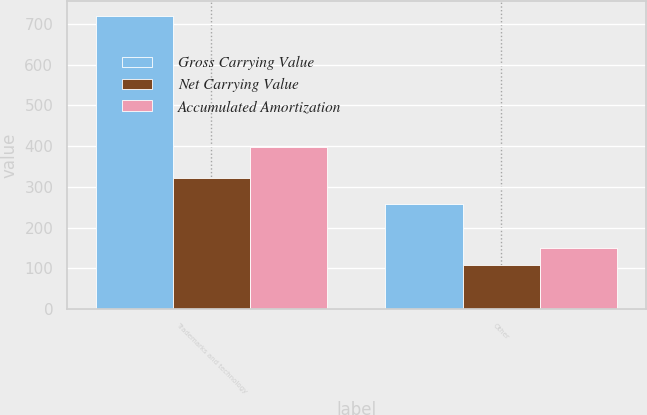Convert chart to OTSL. <chart><loc_0><loc_0><loc_500><loc_500><stacked_bar_chart><ecel><fcel>Trademarks and technology<fcel>Other<nl><fcel>Gross Carrying Value<fcel>720<fcel>258<nl><fcel>Net Carrying Value<fcel>323<fcel>108<nl><fcel>Accumulated Amortization<fcel>397<fcel>150<nl></chart> 